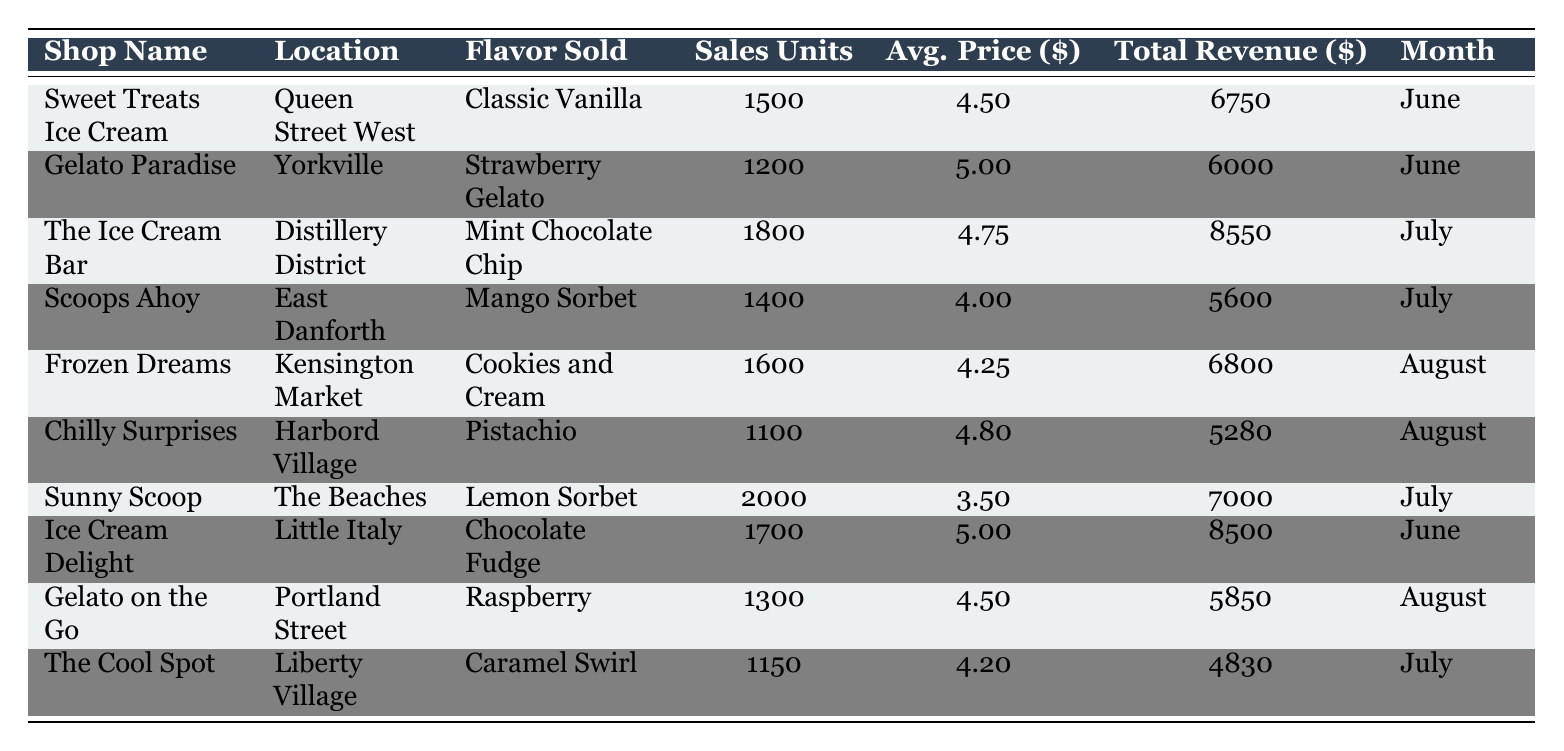What is the total revenue of Ice Cream Delight? The total revenue value for Ice Cream Delight is listed directly in the table, which shows it as 8500.
Answer: 8500 Which flavor sold the most units in July? In July, Sunny Scoop sold 2000 units of Lemon Sorbet, which is the highest among all shops for that month. The Ice Cream Bar sold 1800 units and Scoops Ahoy sold 1400 units, making Lemon Sorbet the top seller.
Answer: Lemon Sorbet How many total sales units were sold across all shops in June? In June, Sweet Treats Ice Cream sold 1500 units, Gelato Paradise sold 1200 units, and Ice Cream Delight sold 1700 units. Adding these gives: 1500 + 1200 + 1700 = 4400 units in total for June.
Answer: 4400 Is the average price of Strawberry Gelato greater than the average price of Pistachio? The average price for Strawberry Gelato is 5.00, while the average price for Pistachio is 4.80. Since 5.00 is greater than 4.80, the statement is true.
Answer: Yes What is the total revenue generated by all shops in August combined? The total revenue for August involves adding the revenues of Frozen Dreams (6800), Chilly Surprises (5280), and Gelato on the Go (5850): 6800 + 5280 + 5850 = 17930. Therefore, the total revenue for August is 17930.
Answer: 17930 Which shop has the highest average price of ice cream, and what is that price? Reviewing the average prices, Gelato Paradise has the highest at 5.00. No other shop matches or exceeds this price among the provided data.
Answer: 5.00 How many more sales units did The Ice Cream Bar sell than Scoops Ahoy in July? The Ice Cream Bar sold 1800 units, while Scoops Ahoy sold 1400 units. The difference can be calculated as 1800 - 1400 = 400. Thus, The Ice Cream Bar sold 400 more units than Scoops Ahoy.
Answer: 400 What was the most popular flavor sold in August? In August, Frozen Dreams sold 1600 units of Cookies and Cream, Chilly Surprises sold 1100 units of Pistachio, and Gelato on the Go sold 1300 units of Raspberry. Cookies and Cream had the highest sales units, making it the most popular flavor for August.
Answer: Cookies and Cream Which shop, located in The Beaches, sold 2000 units? The shop located in The Beaches that sold 2000 units is Sunny Scoop. This specific detail is clearly mentioned in the table.
Answer: Sunny Scoop 